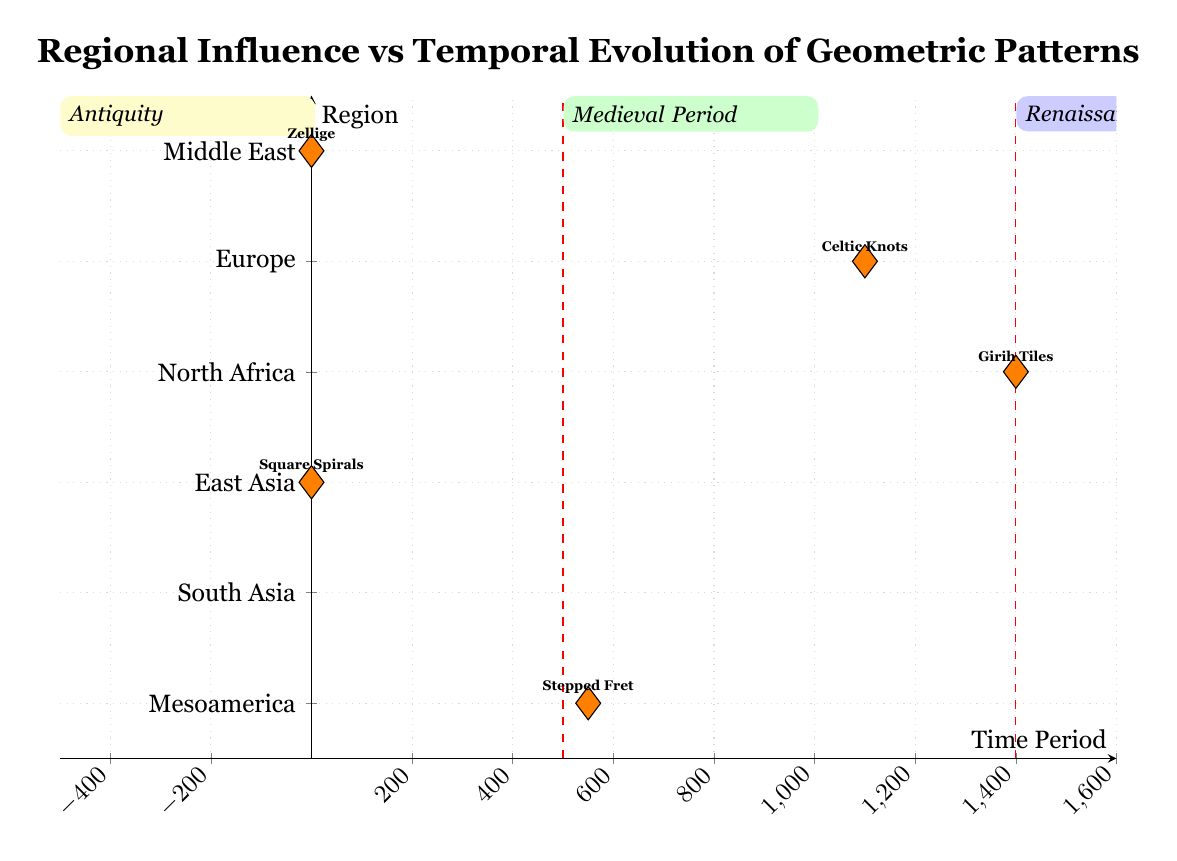What's the pattern type for the Persian Empire? The diagram shows that the Persian Empire, located in the Middle East during the time period of 500 BCE - 500 CE, is associated with the pattern type 'Zellige'
Answer: Zellige Which culture corresponds to the geometric pattern 'Celtic Knots'? Looking at the diagram, the pattern type 'Celtic Knots' is associated with the Medieval European culture, specifically in the time period of 800 CE - 1400 CE
Answer: Medieval European How many pattern types are represented in the Antiquity quadrant? In the Antiquity quadrant, there are three points plotted: 'Zellige', 'Square Spirals', and 'Dot and Circle', indicating three distinct pattern types
Answer: 3 Which region features geometric patterns from 200 CE to 900 CE? The diagram indicates that the Mesoamerican region corresponds to the time period of 200 CE - 900 CE based on the plotted point labeled 'Stepped Fret'
Answer: Mesoamerica What is the earliest time period represented in the diagram? The earliest time period indicated in the diagram is before 500 CE, which falls within the Antiquity quadrant
Answer: Before 500 CE What type of reasoning is needed to identify the relationship between Girih Tiles and the Renaissance? To establish the relationship, we need to observe that 'Girih Tiles' corresponds to the North Africa region during the time period of 1400 CE - 1600 CE, which falls within the Renaissance quadrant of the diagram
Answer: Girih Tiles in North Africa In which quadrant would you find the pattern 'Stepped Fret'? By examining the diagram, 'Stepped Fret' is plotted at 550, which is within the Medieval Period quadrant (500 CE - 1400 CE)
Answer: Medieval Period How does the time period of the Han Dynasty compare to the pattern type from the Middle East? The Han Dynasty falls into the time period of 200 BCE - 200 CE; comparing this to the Middle East's Zellige from 500 BCE - 500 CE, it is clear that they both belong to the Antiquity quadrant with overlapping timelines
Answer: Antiquity What is the regional association of geometric patterns during the Medieval Period? The Medieval Period, denoted in the diagram, comprises the regions of Europe and North Africa, indicating the cultural diversity in geometric patterns produced in that time
Answer: Europe and North Africa 